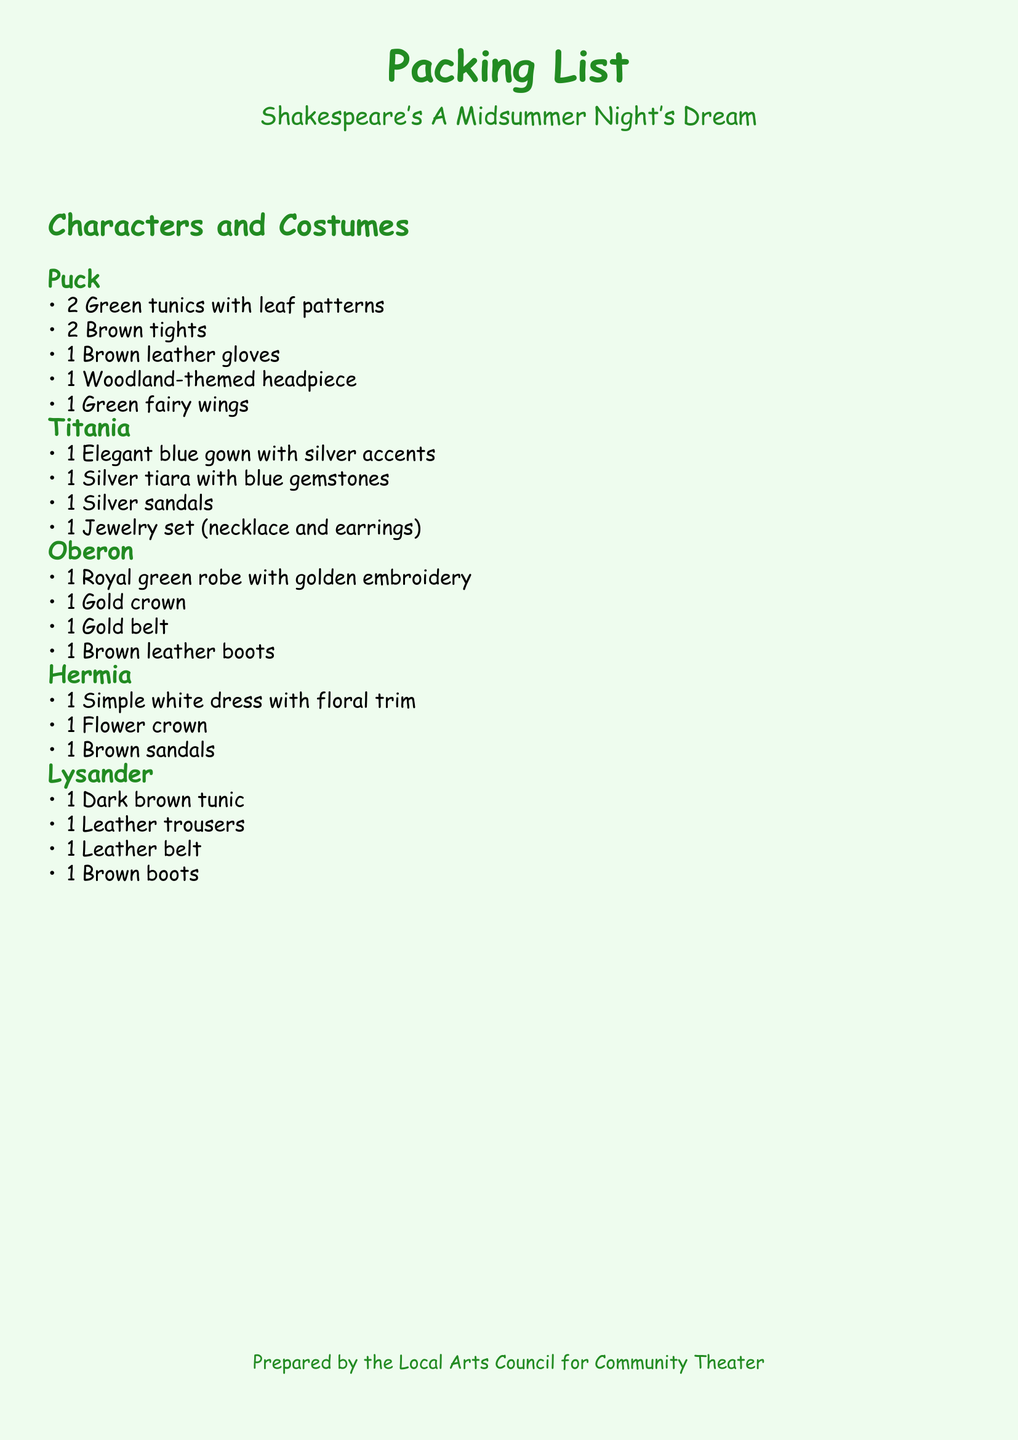What is the title of the play? The title of the play is mentioned prominently at the beginning of the document.
Answer: A Midsummer Night's Dream How many green tunics does Puck need? The document lists the specific quantity of each costume item for Puck.
Answer: 2 What color is Titania's gown? The description of Titania's gown specifies its color clearly.
Answer: Blue Which character wears a gold crown? The character associated with the gold crown is mentioned in the section detailing their costumes.
Answer: Oberon How many items are listed for Hermia? The total number of costume items for Hermia is calculated by counting each bullet point listed.
Answer: 3 What type of shoes does Hermia wear? The specific type of footwear for each character is detailed in their respective sections.
Answer: Brown sandals What additional accessory does Lysander need? The document specifies the items required for Lysander, including additional accessories.
Answer: Leather belt What theme is associated with Puck's headpiece? The description of Puck's headpiece indicates its thematic inspiration.
Answer: Woodland What jewelry set is Titania supposed to wear? The document lists the components of Titania's jewelry set explicitly.
Answer: Necklace and earrings 